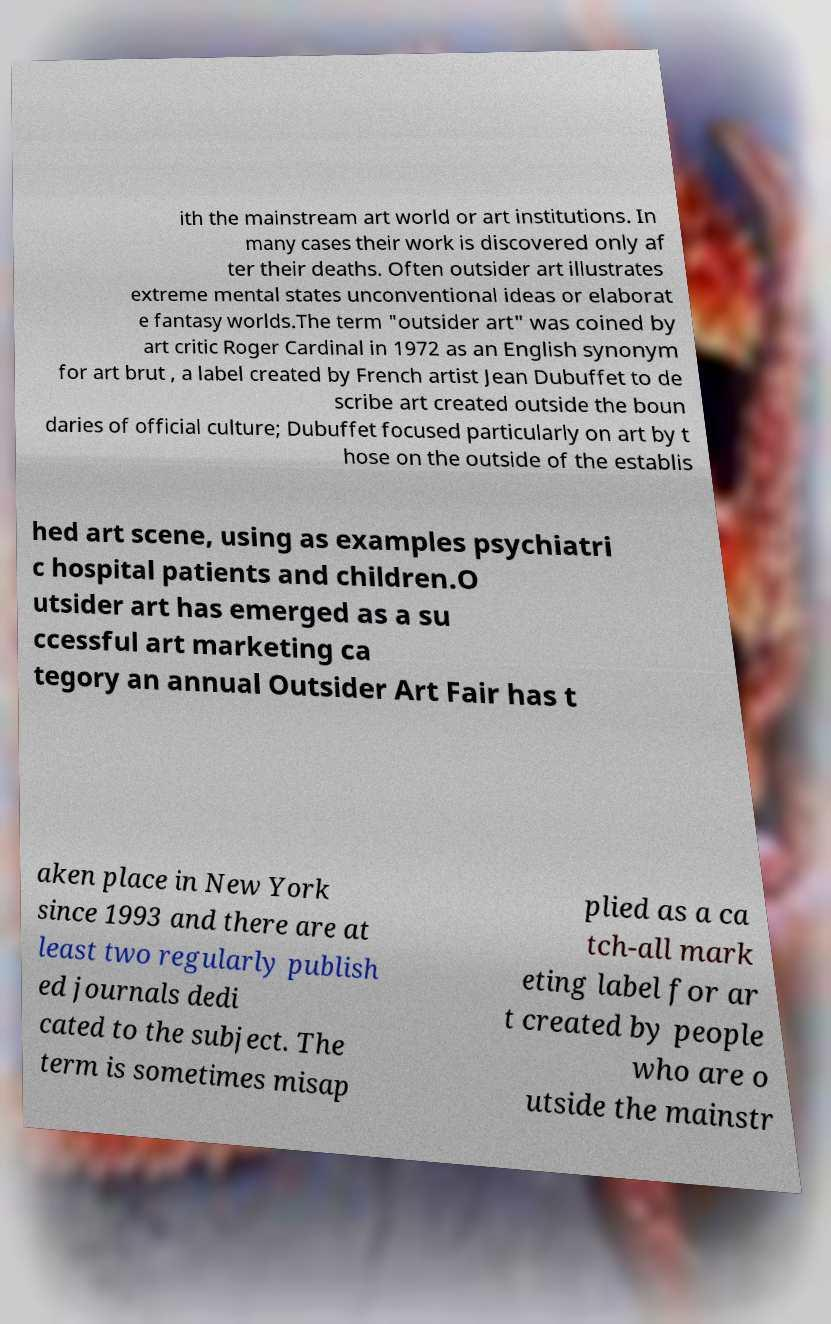There's text embedded in this image that I need extracted. Can you transcribe it verbatim? ith the mainstream art world or art institutions. In many cases their work is discovered only af ter their deaths. Often outsider art illustrates extreme mental states unconventional ideas or elaborat e fantasy worlds.The term "outsider art" was coined by art critic Roger Cardinal in 1972 as an English synonym for art brut , a label created by French artist Jean Dubuffet to de scribe art created outside the boun daries of official culture; Dubuffet focused particularly on art by t hose on the outside of the establis hed art scene, using as examples psychiatri c hospital patients and children.O utsider art has emerged as a su ccessful art marketing ca tegory an annual Outsider Art Fair has t aken place in New York since 1993 and there are at least two regularly publish ed journals dedi cated to the subject. The term is sometimes misap plied as a ca tch-all mark eting label for ar t created by people who are o utside the mainstr 